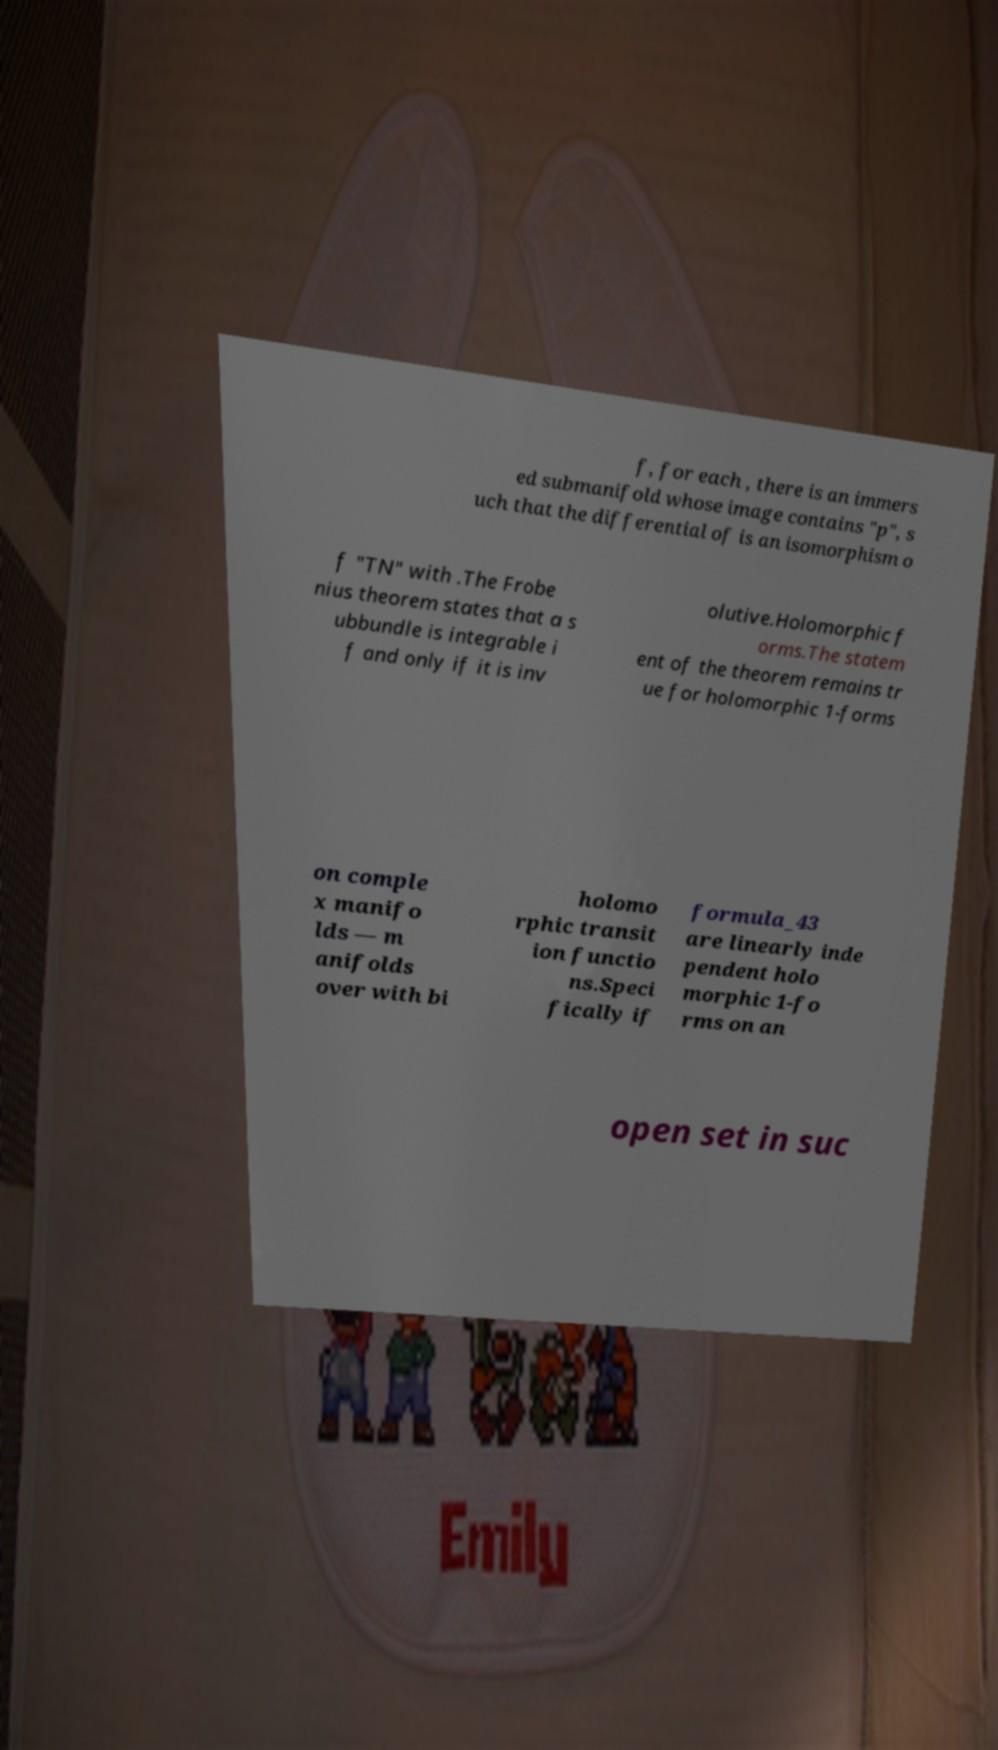What messages or text are displayed in this image? I need them in a readable, typed format. f, for each , there is an immers ed submanifold whose image contains "p", s uch that the differential of is an isomorphism o f "TN" with .The Frobe nius theorem states that a s ubbundle is integrable i f and only if it is inv olutive.Holomorphic f orms.The statem ent of the theorem remains tr ue for holomorphic 1-forms on comple x manifo lds — m anifolds over with bi holomo rphic transit ion functio ns.Speci fically if formula_43 are linearly inde pendent holo morphic 1-fo rms on an open set in suc 